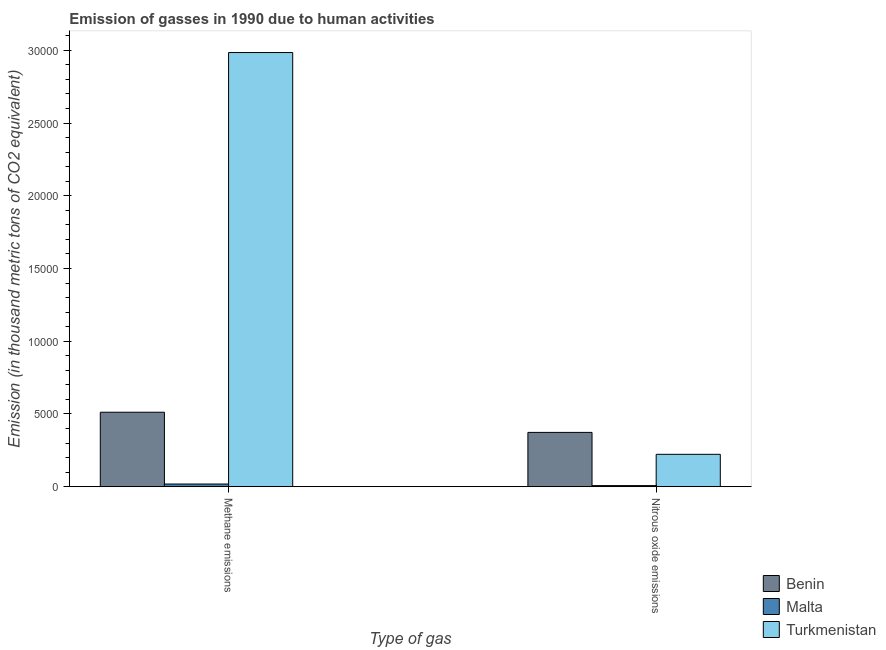How many different coloured bars are there?
Ensure brevity in your answer.  3. How many groups of bars are there?
Make the answer very short. 2. Are the number of bars per tick equal to the number of legend labels?
Offer a very short reply. Yes. Are the number of bars on each tick of the X-axis equal?
Your response must be concise. Yes. How many bars are there on the 1st tick from the right?
Make the answer very short. 3. What is the label of the 2nd group of bars from the left?
Offer a terse response. Nitrous oxide emissions. What is the amount of nitrous oxide emissions in Benin?
Your response must be concise. 3732.5. Across all countries, what is the maximum amount of nitrous oxide emissions?
Keep it short and to the point. 3732.5. Across all countries, what is the minimum amount of nitrous oxide emissions?
Give a very brief answer. 74.4. In which country was the amount of nitrous oxide emissions maximum?
Your answer should be very brief. Benin. In which country was the amount of methane emissions minimum?
Offer a terse response. Malta. What is the total amount of nitrous oxide emissions in the graph?
Keep it short and to the point. 6032. What is the difference between the amount of nitrous oxide emissions in Malta and that in Benin?
Offer a very short reply. -3658.1. What is the difference between the amount of nitrous oxide emissions in Turkmenistan and the amount of methane emissions in Malta?
Give a very brief answer. 2041.4. What is the average amount of nitrous oxide emissions per country?
Offer a very short reply. 2010.67. What is the difference between the amount of nitrous oxide emissions and amount of methane emissions in Malta?
Your answer should be very brief. -109.3. What is the ratio of the amount of methane emissions in Benin to that in Turkmenistan?
Provide a succinct answer. 0.17. In how many countries, is the amount of methane emissions greater than the average amount of methane emissions taken over all countries?
Offer a terse response. 1. What does the 2nd bar from the left in Methane emissions represents?
Offer a very short reply. Malta. What does the 3rd bar from the right in Nitrous oxide emissions represents?
Provide a short and direct response. Benin. How many countries are there in the graph?
Offer a very short reply. 3. Does the graph contain any zero values?
Ensure brevity in your answer.  No. Does the graph contain grids?
Your answer should be compact. No. How many legend labels are there?
Your response must be concise. 3. What is the title of the graph?
Offer a terse response. Emission of gasses in 1990 due to human activities. What is the label or title of the X-axis?
Your answer should be very brief. Type of gas. What is the label or title of the Y-axis?
Ensure brevity in your answer.  Emission (in thousand metric tons of CO2 equivalent). What is the Emission (in thousand metric tons of CO2 equivalent) in Benin in Methane emissions?
Make the answer very short. 5119.5. What is the Emission (in thousand metric tons of CO2 equivalent) of Malta in Methane emissions?
Give a very brief answer. 183.7. What is the Emission (in thousand metric tons of CO2 equivalent) in Turkmenistan in Methane emissions?
Your response must be concise. 2.98e+04. What is the Emission (in thousand metric tons of CO2 equivalent) of Benin in Nitrous oxide emissions?
Provide a short and direct response. 3732.5. What is the Emission (in thousand metric tons of CO2 equivalent) in Malta in Nitrous oxide emissions?
Give a very brief answer. 74.4. What is the Emission (in thousand metric tons of CO2 equivalent) of Turkmenistan in Nitrous oxide emissions?
Provide a short and direct response. 2225.1. Across all Type of gas, what is the maximum Emission (in thousand metric tons of CO2 equivalent) in Benin?
Your answer should be very brief. 5119.5. Across all Type of gas, what is the maximum Emission (in thousand metric tons of CO2 equivalent) of Malta?
Give a very brief answer. 183.7. Across all Type of gas, what is the maximum Emission (in thousand metric tons of CO2 equivalent) of Turkmenistan?
Keep it short and to the point. 2.98e+04. Across all Type of gas, what is the minimum Emission (in thousand metric tons of CO2 equivalent) of Benin?
Your response must be concise. 3732.5. Across all Type of gas, what is the minimum Emission (in thousand metric tons of CO2 equivalent) in Malta?
Your response must be concise. 74.4. Across all Type of gas, what is the minimum Emission (in thousand metric tons of CO2 equivalent) in Turkmenistan?
Provide a short and direct response. 2225.1. What is the total Emission (in thousand metric tons of CO2 equivalent) of Benin in the graph?
Ensure brevity in your answer.  8852. What is the total Emission (in thousand metric tons of CO2 equivalent) of Malta in the graph?
Your answer should be compact. 258.1. What is the total Emission (in thousand metric tons of CO2 equivalent) in Turkmenistan in the graph?
Keep it short and to the point. 3.21e+04. What is the difference between the Emission (in thousand metric tons of CO2 equivalent) in Benin in Methane emissions and that in Nitrous oxide emissions?
Keep it short and to the point. 1387. What is the difference between the Emission (in thousand metric tons of CO2 equivalent) in Malta in Methane emissions and that in Nitrous oxide emissions?
Provide a short and direct response. 109.3. What is the difference between the Emission (in thousand metric tons of CO2 equivalent) in Turkmenistan in Methane emissions and that in Nitrous oxide emissions?
Ensure brevity in your answer.  2.76e+04. What is the difference between the Emission (in thousand metric tons of CO2 equivalent) in Benin in Methane emissions and the Emission (in thousand metric tons of CO2 equivalent) in Malta in Nitrous oxide emissions?
Give a very brief answer. 5045.1. What is the difference between the Emission (in thousand metric tons of CO2 equivalent) of Benin in Methane emissions and the Emission (in thousand metric tons of CO2 equivalent) of Turkmenistan in Nitrous oxide emissions?
Provide a short and direct response. 2894.4. What is the difference between the Emission (in thousand metric tons of CO2 equivalent) of Malta in Methane emissions and the Emission (in thousand metric tons of CO2 equivalent) of Turkmenistan in Nitrous oxide emissions?
Give a very brief answer. -2041.4. What is the average Emission (in thousand metric tons of CO2 equivalent) of Benin per Type of gas?
Keep it short and to the point. 4426. What is the average Emission (in thousand metric tons of CO2 equivalent) of Malta per Type of gas?
Provide a short and direct response. 129.05. What is the average Emission (in thousand metric tons of CO2 equivalent) in Turkmenistan per Type of gas?
Your answer should be very brief. 1.60e+04. What is the difference between the Emission (in thousand metric tons of CO2 equivalent) in Benin and Emission (in thousand metric tons of CO2 equivalent) in Malta in Methane emissions?
Offer a very short reply. 4935.8. What is the difference between the Emission (in thousand metric tons of CO2 equivalent) of Benin and Emission (in thousand metric tons of CO2 equivalent) of Turkmenistan in Methane emissions?
Give a very brief answer. -2.47e+04. What is the difference between the Emission (in thousand metric tons of CO2 equivalent) in Malta and Emission (in thousand metric tons of CO2 equivalent) in Turkmenistan in Methane emissions?
Your answer should be very brief. -2.97e+04. What is the difference between the Emission (in thousand metric tons of CO2 equivalent) in Benin and Emission (in thousand metric tons of CO2 equivalent) in Malta in Nitrous oxide emissions?
Provide a succinct answer. 3658.1. What is the difference between the Emission (in thousand metric tons of CO2 equivalent) in Benin and Emission (in thousand metric tons of CO2 equivalent) in Turkmenistan in Nitrous oxide emissions?
Make the answer very short. 1507.4. What is the difference between the Emission (in thousand metric tons of CO2 equivalent) in Malta and Emission (in thousand metric tons of CO2 equivalent) in Turkmenistan in Nitrous oxide emissions?
Provide a succinct answer. -2150.7. What is the ratio of the Emission (in thousand metric tons of CO2 equivalent) in Benin in Methane emissions to that in Nitrous oxide emissions?
Keep it short and to the point. 1.37. What is the ratio of the Emission (in thousand metric tons of CO2 equivalent) in Malta in Methane emissions to that in Nitrous oxide emissions?
Provide a short and direct response. 2.47. What is the ratio of the Emission (in thousand metric tons of CO2 equivalent) in Turkmenistan in Methane emissions to that in Nitrous oxide emissions?
Ensure brevity in your answer.  13.41. What is the difference between the highest and the second highest Emission (in thousand metric tons of CO2 equivalent) of Benin?
Keep it short and to the point. 1387. What is the difference between the highest and the second highest Emission (in thousand metric tons of CO2 equivalent) of Malta?
Make the answer very short. 109.3. What is the difference between the highest and the second highest Emission (in thousand metric tons of CO2 equivalent) of Turkmenistan?
Offer a terse response. 2.76e+04. What is the difference between the highest and the lowest Emission (in thousand metric tons of CO2 equivalent) in Benin?
Provide a succinct answer. 1387. What is the difference between the highest and the lowest Emission (in thousand metric tons of CO2 equivalent) in Malta?
Your answer should be compact. 109.3. What is the difference between the highest and the lowest Emission (in thousand metric tons of CO2 equivalent) of Turkmenistan?
Your response must be concise. 2.76e+04. 